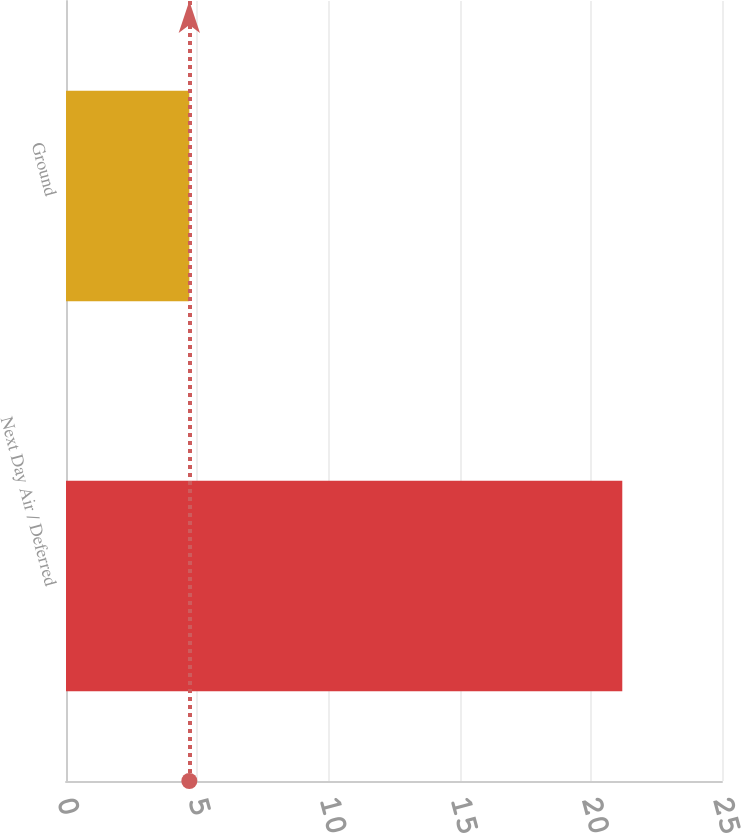<chart> <loc_0><loc_0><loc_500><loc_500><bar_chart><fcel>Next Day Air / Deferred<fcel>Ground<nl><fcel>21.2<fcel>4.7<nl></chart> 